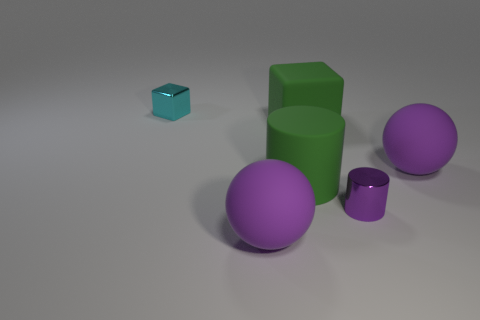Add 1 tiny cyan cubes. How many objects exist? 7 Subtract all green blocks. How many blocks are left? 1 Subtract all blocks. How many objects are left? 4 Subtract 2 spheres. How many spheres are left? 0 Subtract all green rubber cylinders. Subtract all large brown spheres. How many objects are left? 5 Add 4 large green cylinders. How many large green cylinders are left? 5 Add 5 gray metallic spheres. How many gray metallic spheres exist? 5 Subtract 1 green cylinders. How many objects are left? 5 Subtract all yellow balls. Subtract all yellow cylinders. How many balls are left? 2 